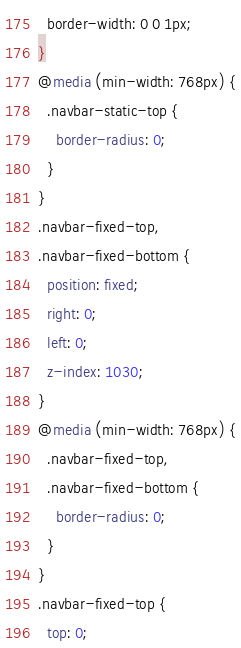Convert code to text. <code><loc_0><loc_0><loc_500><loc_500><_CSS_>  border-width: 0 0 1px;
}
@media (min-width: 768px) {
  .navbar-static-top {
    border-radius: 0;
  }
}
.navbar-fixed-top,
.navbar-fixed-bottom {
  position: fixed;
  right: 0;
  left: 0;
  z-index: 1030;
}
@media (min-width: 768px) {
  .navbar-fixed-top,
  .navbar-fixed-bottom {
    border-radius: 0;
  }
}
.navbar-fixed-top {
  top: 0;</code> 